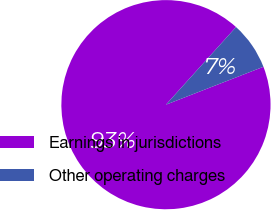Convert chart. <chart><loc_0><loc_0><loc_500><loc_500><pie_chart><fcel>Earnings in jurisdictions<fcel>Other operating charges<nl><fcel>92.59%<fcel>7.41%<nl></chart> 